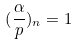Convert formula to latex. <formula><loc_0><loc_0><loc_500><loc_500>( \frac { \alpha } { p } ) _ { n } = 1</formula> 